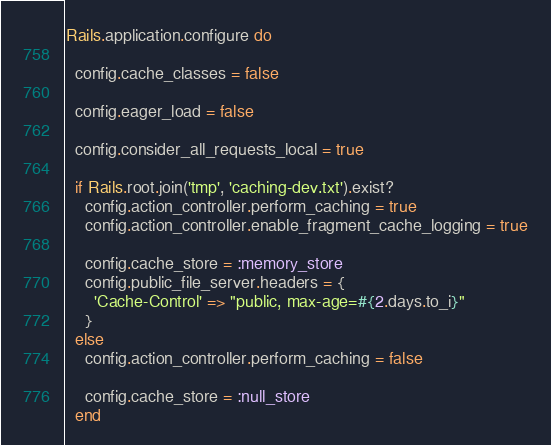Convert code to text. <code><loc_0><loc_0><loc_500><loc_500><_Ruby_>Rails.application.configure do
  
  config.cache_classes = false

  config.eager_load = false

  config.consider_all_requests_local = true

  if Rails.root.join('tmp', 'caching-dev.txt').exist?
    config.action_controller.perform_caching = true
    config.action_controller.enable_fragment_cache_logging = true

    config.cache_store = :memory_store
    config.public_file_server.headers = {
      'Cache-Control' => "public, max-age=#{2.days.to_i}"
    }
  else
    config.action_controller.perform_caching = false

    config.cache_store = :null_store
  end
</code> 